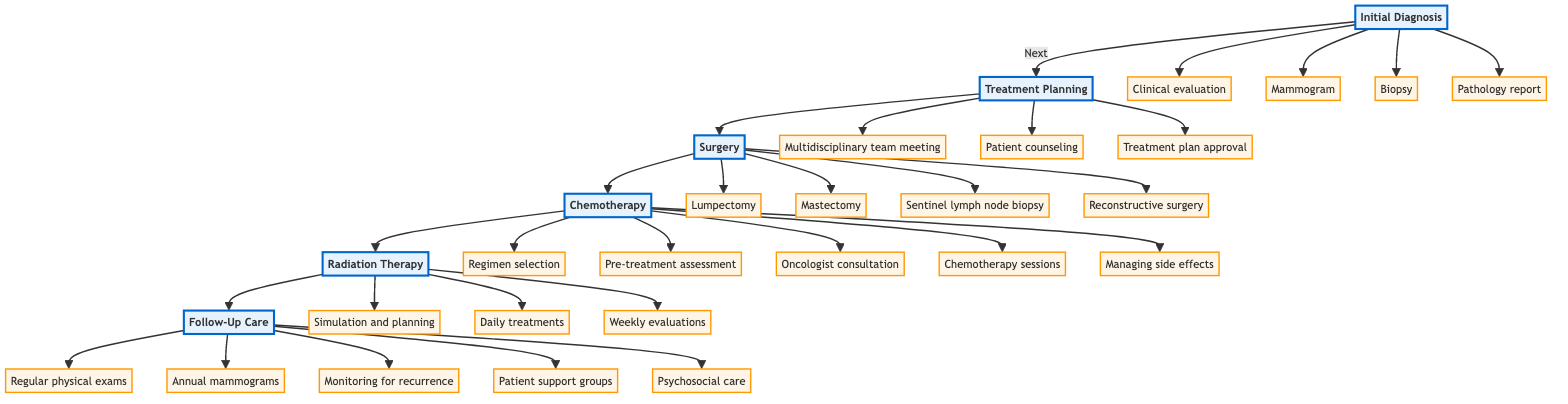What is the first step in the Breast Cancer Treatment Pathway? The first step is indicated by the first node in the flowchart, which is "Initial Diagnosis".
Answer: Initial Diagnosis How many treatment steps are depicted in the pathway? Counting the steps shown in the diagram gives a total of five treatment steps: Initial Diagnosis, Treatment Planning, Surgery, Chemotherapy, and Follow-Up Care.
Answer: 5 What process is involved in the Treatment Planning step? In the Treatment Planning step, the processes listed are: multidisciplinary team meeting, patient counseling, and treatment plan approval. These can be identified in the corresponding node that follows Initial Diagnosis.
Answer: Multidisciplinary team meeting, patient counseling, treatment plan approval Which treatment follows after Surgery? The diagram shows that Chemotherapy directly follows the Surgery step. This is seen by the arrow directed from Surgery to Chemotherapy.
Answer: Chemotherapy What are the processes included in Follow-Up Care? The Follow-Up Care step includes the following processes: regular physical exams, annual mammograms, monitoring for recurrence, patient support groups, and psychosocial care. These can be found in the respective node linked after Radiation Therapy.
Answer: Regular physical exams, annual mammograms, monitoring for recurrence, patient support groups, psychosocial care Which step involves a multidisciplinary team? The only step that involves a multidisciplinary team is the Treatment Planning step, as indicated by the associated processes rooted to this node in the diagram.
Answer: Treatment Planning How many processes are listed under the Surgery step? In the Surgery step, there are four distinct processes: lumpectomy, mastectomy, sentinel lymph node biopsy, and reconstructive surgery, as indicated in the flowchart.
Answer: 4 What follows Radiation Therapy in the pathway? The diagram indicates that Follow-Up Care follows the Radiation Therapy step, as demonstrated by the arrow connecting these two nodes.
Answer: Follow-Up Care 